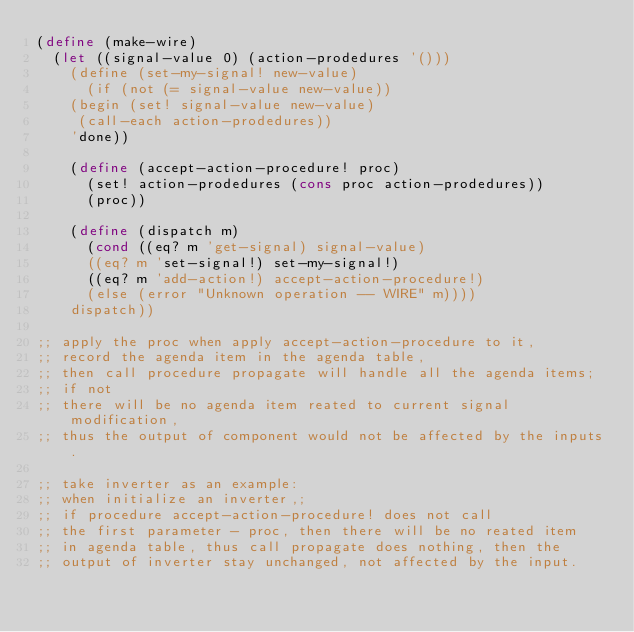<code> <loc_0><loc_0><loc_500><loc_500><_Scheme_>(define (make-wire)
  (let ((signal-value 0) (action-prodedures '()))
    (define (set-my-signal! new-value)
      (if (not (= signal-value new-value))
	  (begin (set! signal-value new-value)
		 (call-each action-prodedures))
	  'done))
    
    (define (accept-action-procedure! proc)
      (set! action-prodedures (cons proc action-prodedures))
      (proc))

    (define (dispatch m)
      (cond ((eq? m 'get-signal) signal-value)
	    ((eq? m 'set-signal!) set-my-signal!)
	    ((eq? m 'add-action!) accept-action-procedure!)
	    (else (error "Unknown operation -- WIRE" m))))
    dispatch))

;; apply the proc when apply accept-action-procedure to it,
;; record the agenda item in the agenda table,
;; then call procedure propagate will handle all the agenda items;
;; if not
;; there will be no agenda item reated to current signal modification,
;; thus the output of component would not be affected by the inputs.

;; take inverter as an example:
;; when initialize an inverter,;
;; if procedure accept-action-procedure! does not call
;; the first parameter - proc, then there will be no reated item
;; in agenda table, thus call propagate does nothing, then the
;; output of inverter stay unchanged, not affected by the input.
</code> 